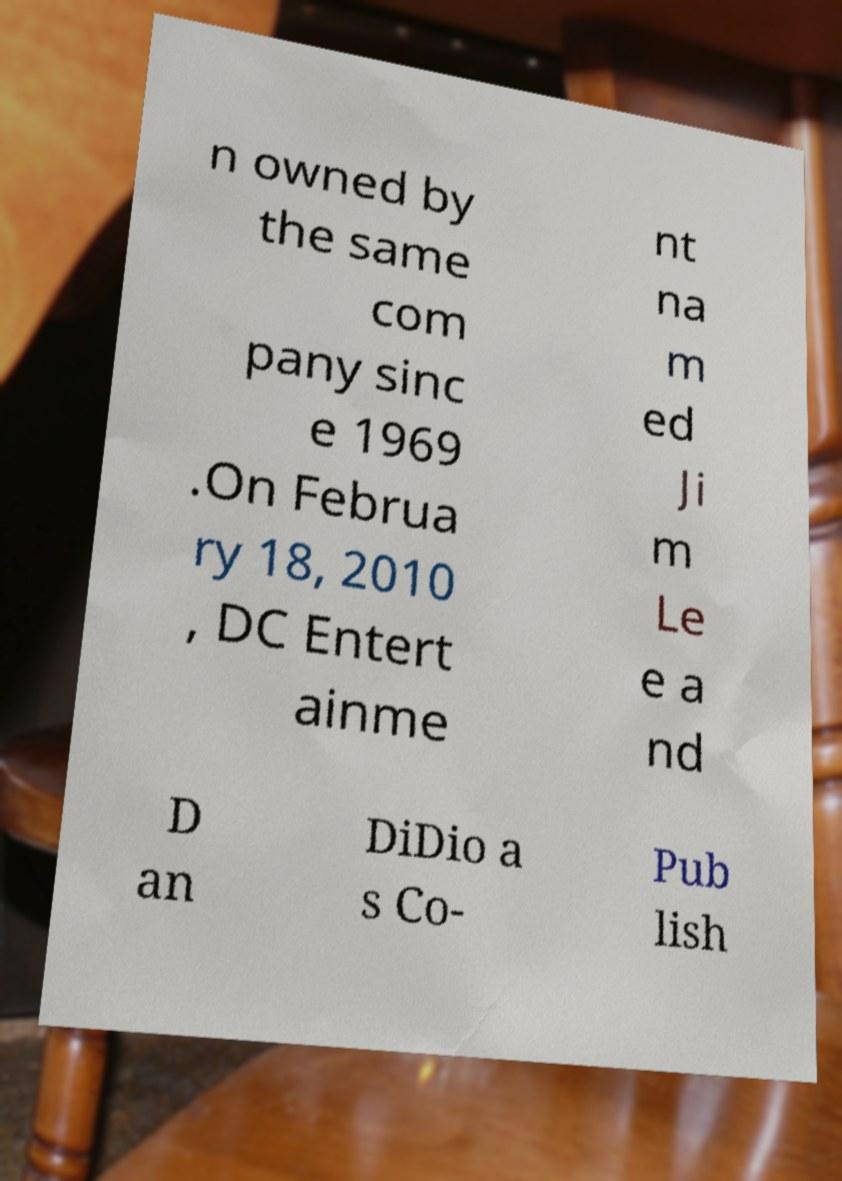What messages or text are displayed in this image? I need them in a readable, typed format. n owned by the same com pany sinc e 1969 .On Februa ry 18, 2010 , DC Entert ainme nt na m ed Ji m Le e a nd D an DiDio a s Co- Pub lish 